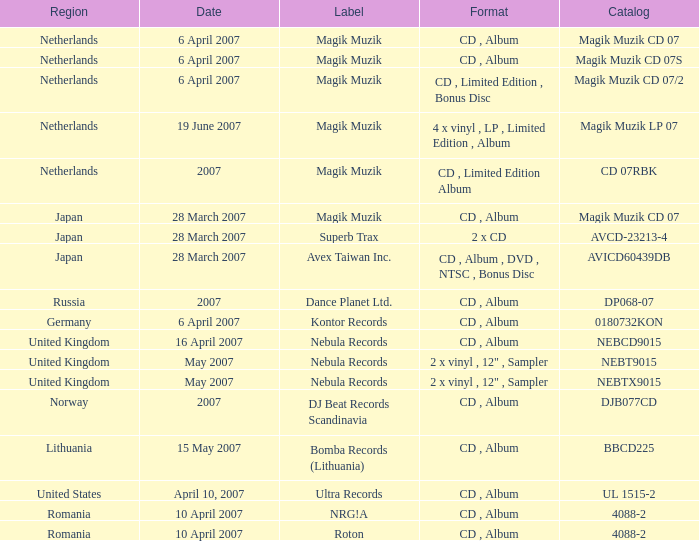For the catalog title DP068-07, what formats are available? CD , Album. Give me the full table as a dictionary. {'header': ['Region', 'Date', 'Label', 'Format', 'Catalog'], 'rows': [['Netherlands', '6 April 2007', 'Magik Muzik', 'CD , Album', 'Magik Muzik CD 07'], ['Netherlands', '6 April 2007', 'Magik Muzik', 'CD , Album', 'Magik Muzik CD 07S'], ['Netherlands', '6 April 2007', 'Magik Muzik', 'CD , Limited Edition , Bonus Disc', 'Magik Muzik CD 07/2'], ['Netherlands', '19 June 2007', 'Magik Muzik', '4 x vinyl , LP , Limited Edition , Album', 'Magik Muzik LP 07'], ['Netherlands', '2007', 'Magik Muzik', 'CD , Limited Edition Album', 'CD 07RBK'], ['Japan', '28 March 2007', 'Magik Muzik', 'CD , Album', 'Magik Muzik CD 07'], ['Japan', '28 March 2007', 'Superb Trax', '2 x CD', 'AVCD-23213-4'], ['Japan', '28 March 2007', 'Avex Taiwan Inc.', 'CD , Album , DVD , NTSC , Bonus Disc', 'AVICD60439DB'], ['Russia', '2007', 'Dance Planet Ltd.', 'CD , Album', 'DP068-07'], ['Germany', '6 April 2007', 'Kontor Records', 'CD , Album', '0180732KON'], ['United Kingdom', '16 April 2007', 'Nebula Records', 'CD , Album', 'NEBCD9015'], ['United Kingdom', 'May 2007', 'Nebula Records', '2 x vinyl , 12" , Sampler', 'NEBT9015'], ['United Kingdom', 'May 2007', 'Nebula Records', '2 x vinyl , 12" , Sampler', 'NEBTX9015'], ['Norway', '2007', 'DJ Beat Records Scandinavia', 'CD , Album', 'DJB077CD'], ['Lithuania', '15 May 2007', 'Bomba Records (Lithuania)', 'CD , Album', 'BBCD225'], ['United States', 'April 10, 2007', 'Ultra Records', 'CD , Album', 'UL 1515-2'], ['Romania', '10 April 2007', 'NRG!A', 'CD , Album', '4088-2'], ['Romania', '10 April 2007', 'Roton', 'CD , Album', '4088-2']]} 